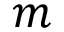Convert formula to latex. <formula><loc_0><loc_0><loc_500><loc_500>m</formula> 